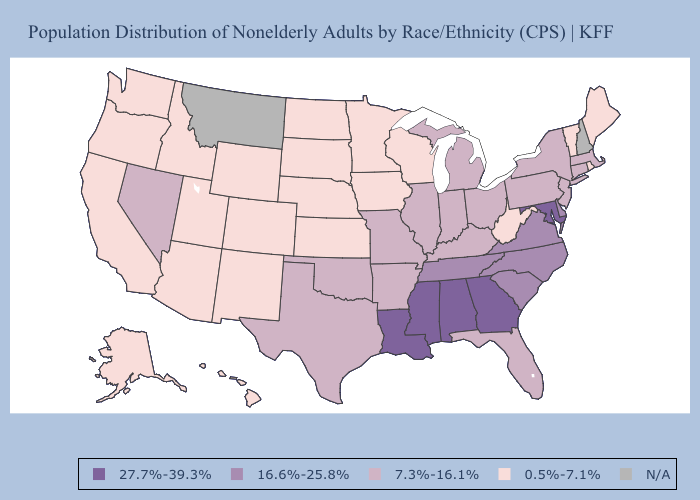Which states have the lowest value in the Northeast?
Be succinct. Maine, Rhode Island, Vermont. Which states have the lowest value in the Northeast?
Write a very short answer. Maine, Rhode Island, Vermont. Name the states that have a value in the range 7.3%-16.1%?
Quick response, please. Arkansas, Connecticut, Florida, Illinois, Indiana, Kentucky, Massachusetts, Michigan, Missouri, Nevada, New Jersey, New York, Ohio, Oklahoma, Pennsylvania, Texas. Does West Virginia have the lowest value in the South?
Be succinct. Yes. Name the states that have a value in the range 16.6%-25.8%?
Be succinct. Delaware, North Carolina, South Carolina, Tennessee, Virginia. Which states have the lowest value in the USA?
Keep it brief. Alaska, Arizona, California, Colorado, Hawaii, Idaho, Iowa, Kansas, Maine, Minnesota, Nebraska, New Mexico, North Dakota, Oregon, Rhode Island, South Dakota, Utah, Vermont, Washington, West Virginia, Wisconsin, Wyoming. Name the states that have a value in the range 27.7%-39.3%?
Write a very short answer. Alabama, Georgia, Louisiana, Maryland, Mississippi. How many symbols are there in the legend?
Keep it brief. 5. Which states have the lowest value in the West?
Be succinct. Alaska, Arizona, California, Colorado, Hawaii, Idaho, New Mexico, Oregon, Utah, Washington, Wyoming. Does New Mexico have the lowest value in the USA?
Write a very short answer. Yes. Name the states that have a value in the range 27.7%-39.3%?
Short answer required. Alabama, Georgia, Louisiana, Maryland, Mississippi. Name the states that have a value in the range 27.7%-39.3%?
Answer briefly. Alabama, Georgia, Louisiana, Maryland, Mississippi. Name the states that have a value in the range N/A?
Short answer required. Montana, New Hampshire. What is the lowest value in the MidWest?
Give a very brief answer. 0.5%-7.1%. 